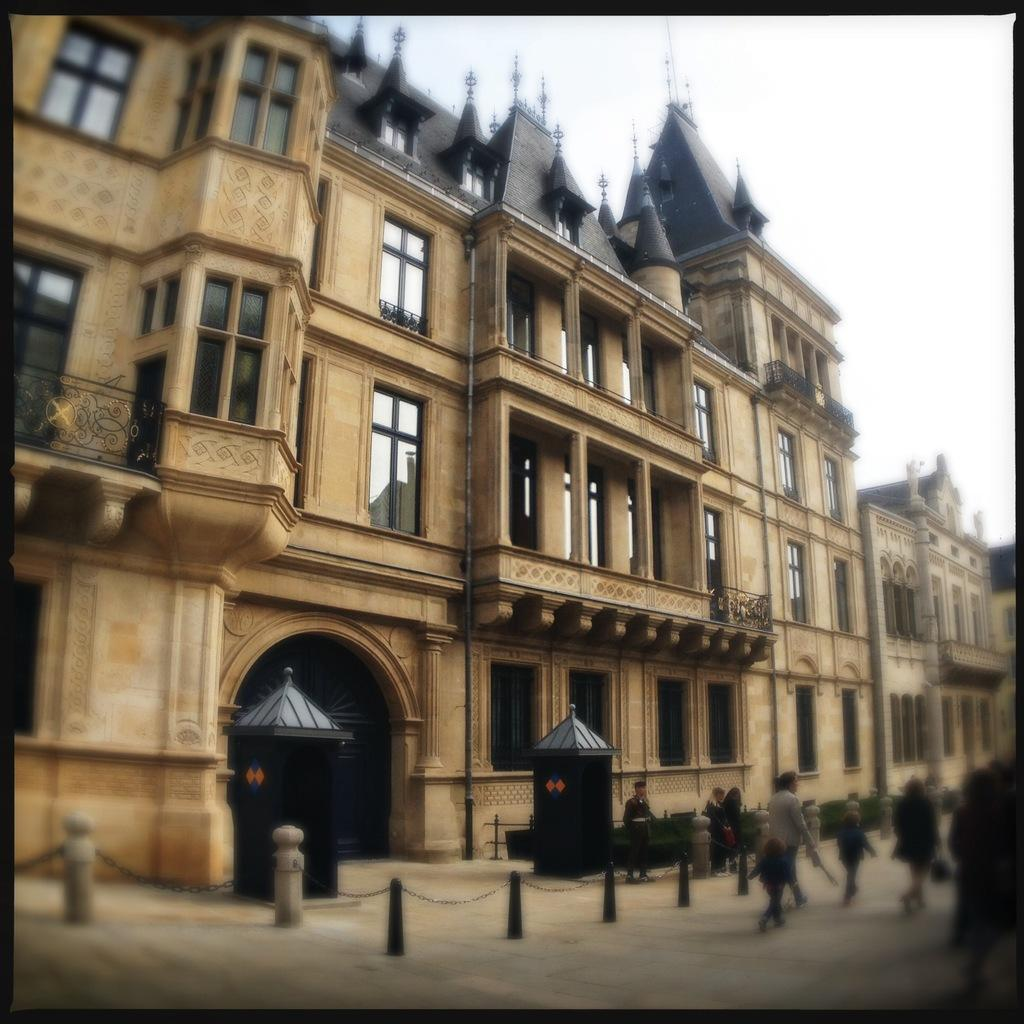What structure is present in the image? There is a building in the image. What are the people in the image doing? The people walking on the right side in the image. Where is the nearest hospital to the building in the image? The provided facts do not mention a hospital or its location, so it cannot be determined from the image. What type of polish is being used by the people walking in the image? There is no indication in the image that the people walking are using any polish. Is there a river visible in the image? The provided facts do not mention a river or its presence, so it cannot be determined from the image. 